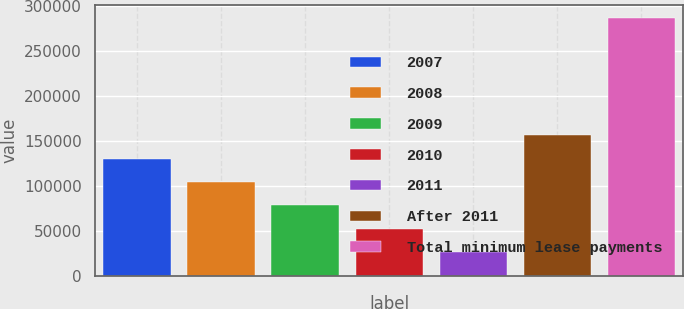<chart> <loc_0><loc_0><loc_500><loc_500><bar_chart><fcel>2007<fcel>2008<fcel>2009<fcel>2010<fcel>2011<fcel>After 2011<fcel>Total minimum lease payments<nl><fcel>130951<fcel>104883<fcel>78814.4<fcel>52746.2<fcel>26678<fcel>157019<fcel>287360<nl></chart> 